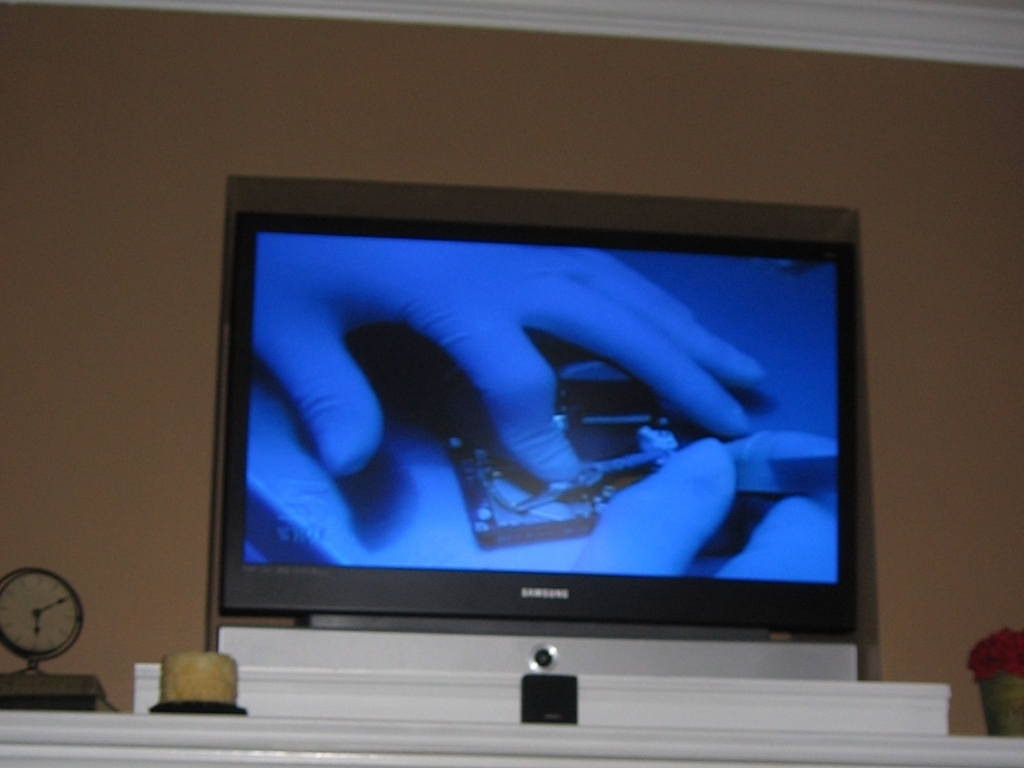What is the overall clarity of the picture?
A. Average
B. Poor
C. Excellent
D. Crystal clear The clarity of the picture can be considered average, option A. The assessment is based on the observable blur and the lack of sharpness in the image, along with the subdued lighting conditions that do not allow for finer details to be discerned clearly. Factors such as the focus on the television screen, reflecting a secondary image, also contribute to the overall average clarity of the photograph. 